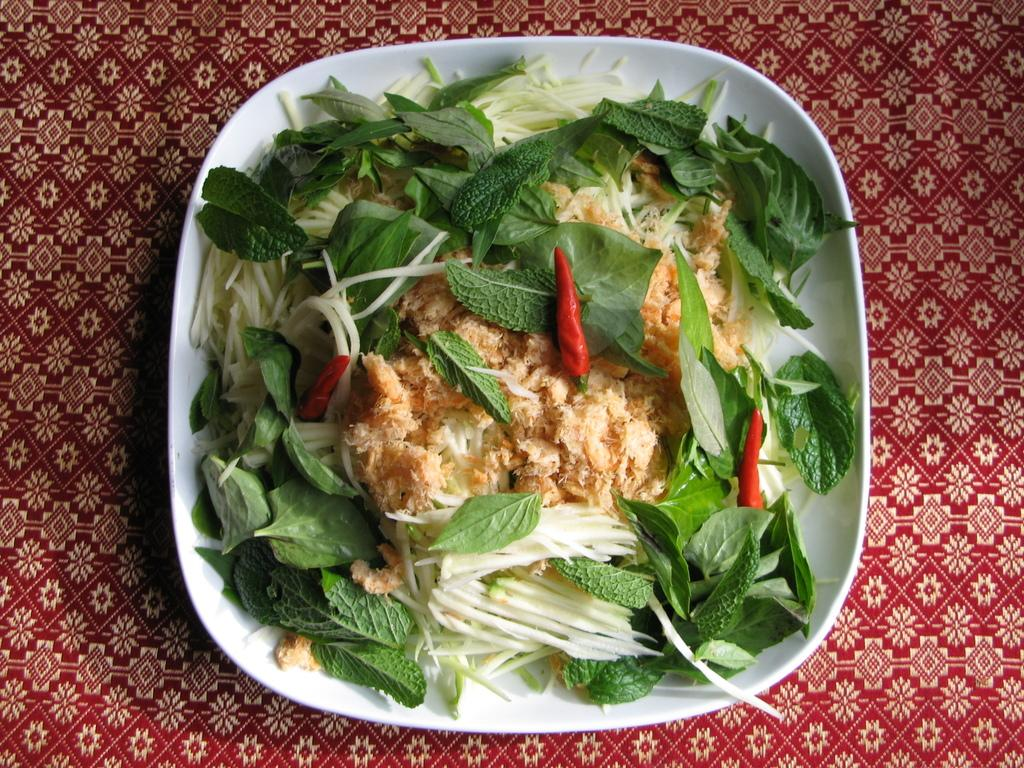What is the main piece of furniture in the image? There is a table in the image. What is placed on the table? There is a bowl on the table. What is inside the bowl? The bowl contains food. What type of detail can be seen on the liquid in the bowl? There is no liquid present in the bowl; it contains food. 